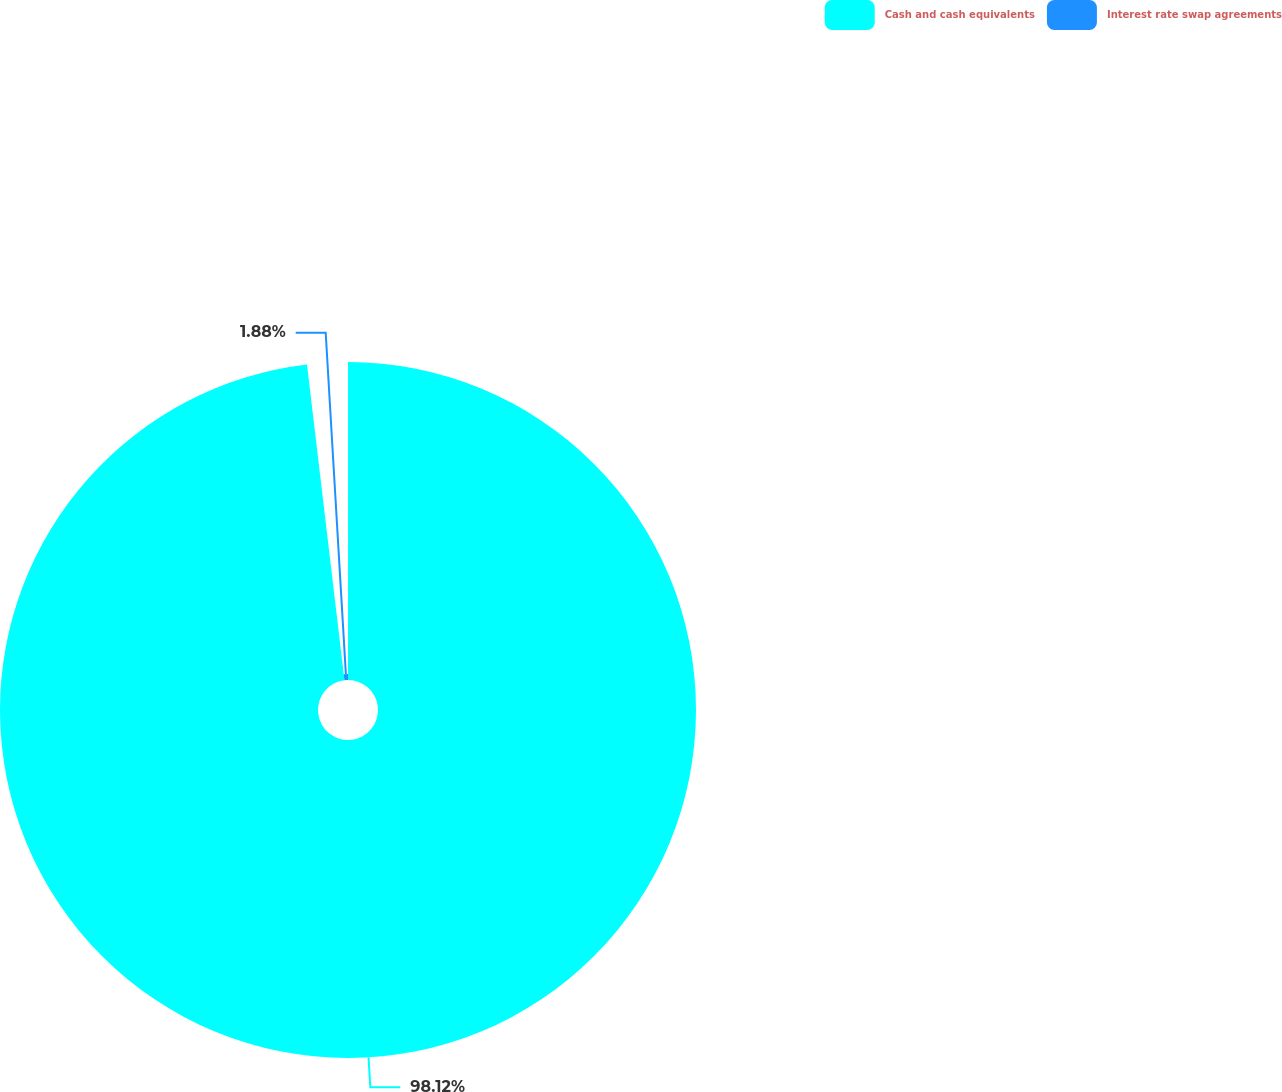Convert chart. <chart><loc_0><loc_0><loc_500><loc_500><pie_chart><fcel>Cash and cash equivalents<fcel>Interest rate swap agreements<nl><fcel>98.12%<fcel>1.88%<nl></chart> 